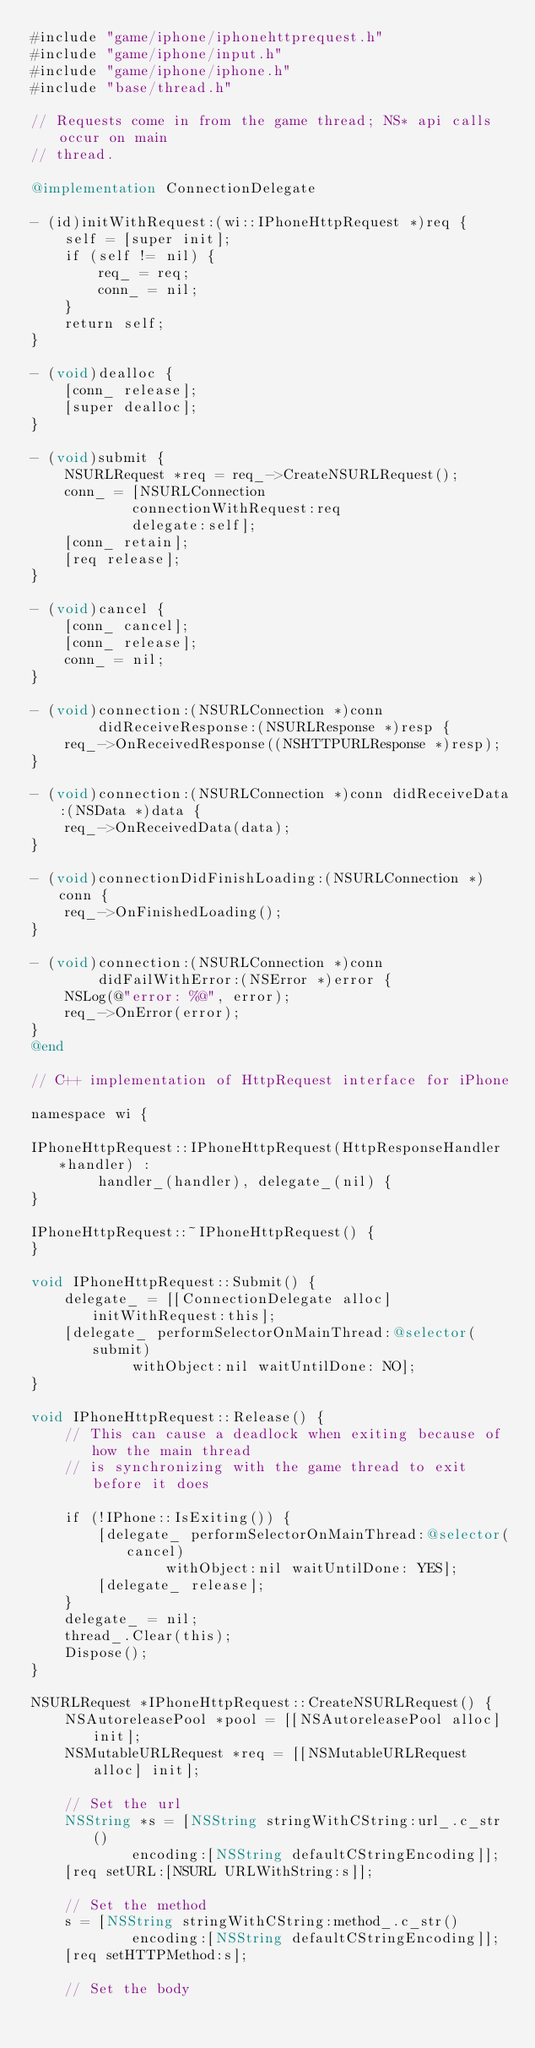<code> <loc_0><loc_0><loc_500><loc_500><_ObjectiveC_>#include "game/iphone/iphonehttprequest.h"
#include "game/iphone/input.h"
#include "game/iphone/iphone.h"
#include "base/thread.h"

// Requests come in from the game thread; NS* api calls occur on main
// thread.

@implementation ConnectionDelegate

- (id)initWithRequest:(wi::IPhoneHttpRequest *)req {
    self = [super init];
    if (self != nil) {
        req_ = req;
        conn_ = nil;
    }
    return self;
}
    
- (void)dealloc {
    [conn_ release];
    [super dealloc];
}

- (void)submit {
    NSURLRequest *req = req_->CreateNSURLRequest();
    conn_ = [NSURLConnection
            connectionWithRequest:req
            delegate:self];
    [conn_ retain];
    [req release];
}

- (void)cancel {
    [conn_ cancel];
    [conn_ release];
    conn_ = nil;
}

- (void)connection:(NSURLConnection *)conn
        didReceiveResponse:(NSURLResponse *)resp {
    req_->OnReceivedResponse((NSHTTPURLResponse *)resp);
}

- (void)connection:(NSURLConnection *)conn didReceiveData:(NSData *)data {
    req_->OnReceivedData(data);
}

- (void)connectionDidFinishLoading:(NSURLConnection *)conn {
    req_->OnFinishedLoading();
}

- (void)connection:(NSURLConnection *)conn
        didFailWithError:(NSError *)error {
    NSLog(@"error: %@", error);
    req_->OnError(error);
}
@end

// C++ implementation of HttpRequest interface for iPhone

namespace wi {

IPhoneHttpRequest::IPhoneHttpRequest(HttpResponseHandler *handler) :
        handler_(handler), delegate_(nil) {
}

IPhoneHttpRequest::~IPhoneHttpRequest() {
}

void IPhoneHttpRequest::Submit() {
    delegate_ = [[ConnectionDelegate alloc] initWithRequest:this];
    [delegate_ performSelectorOnMainThread:@selector(submit)
            withObject:nil waitUntilDone: NO];
}

void IPhoneHttpRequest::Release() {
    // This can cause a deadlock when exiting because of how the main thread
    // is synchronizing with the game thread to exit before it does

    if (!IPhone::IsExiting()) {
        [delegate_ performSelectorOnMainThread:@selector(cancel)
                withObject:nil waitUntilDone: YES];
        [delegate_ release];
    }
    delegate_ = nil;
    thread_.Clear(this);
    Dispose();
}

NSURLRequest *IPhoneHttpRequest::CreateNSURLRequest() {
    NSAutoreleasePool *pool = [[NSAutoreleasePool alloc] init];
    NSMutableURLRequest *req = [[NSMutableURLRequest alloc] init];

    // Set the url
    NSString *s = [NSString stringWithCString:url_.c_str()
            encoding:[NSString defaultCStringEncoding]];
    [req setURL:[NSURL URLWithString:s]];

    // Set the method
    s = [NSString stringWithCString:method_.c_str()
            encoding:[NSString defaultCStringEncoding]];
    [req setHTTPMethod:s];

    // Set the body</code> 